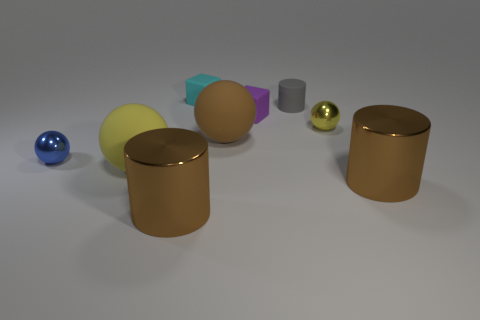Can you describe the colors and materials of the objects in the image? Certainly! In the image, there are objects with a variety of colors and textures: a glossy blue sphere, a matte yellow cylinder, a shiny golden sphere, a transparent purple cuboid, a matte beige sphere, a small shiny silver cylinder, and two larger metallic copper cylinders—all resting on a neutral surface against a blank background. 